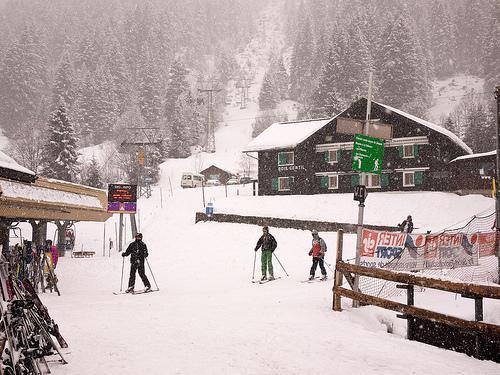How many people are outside?
Give a very brief answer. 5. 